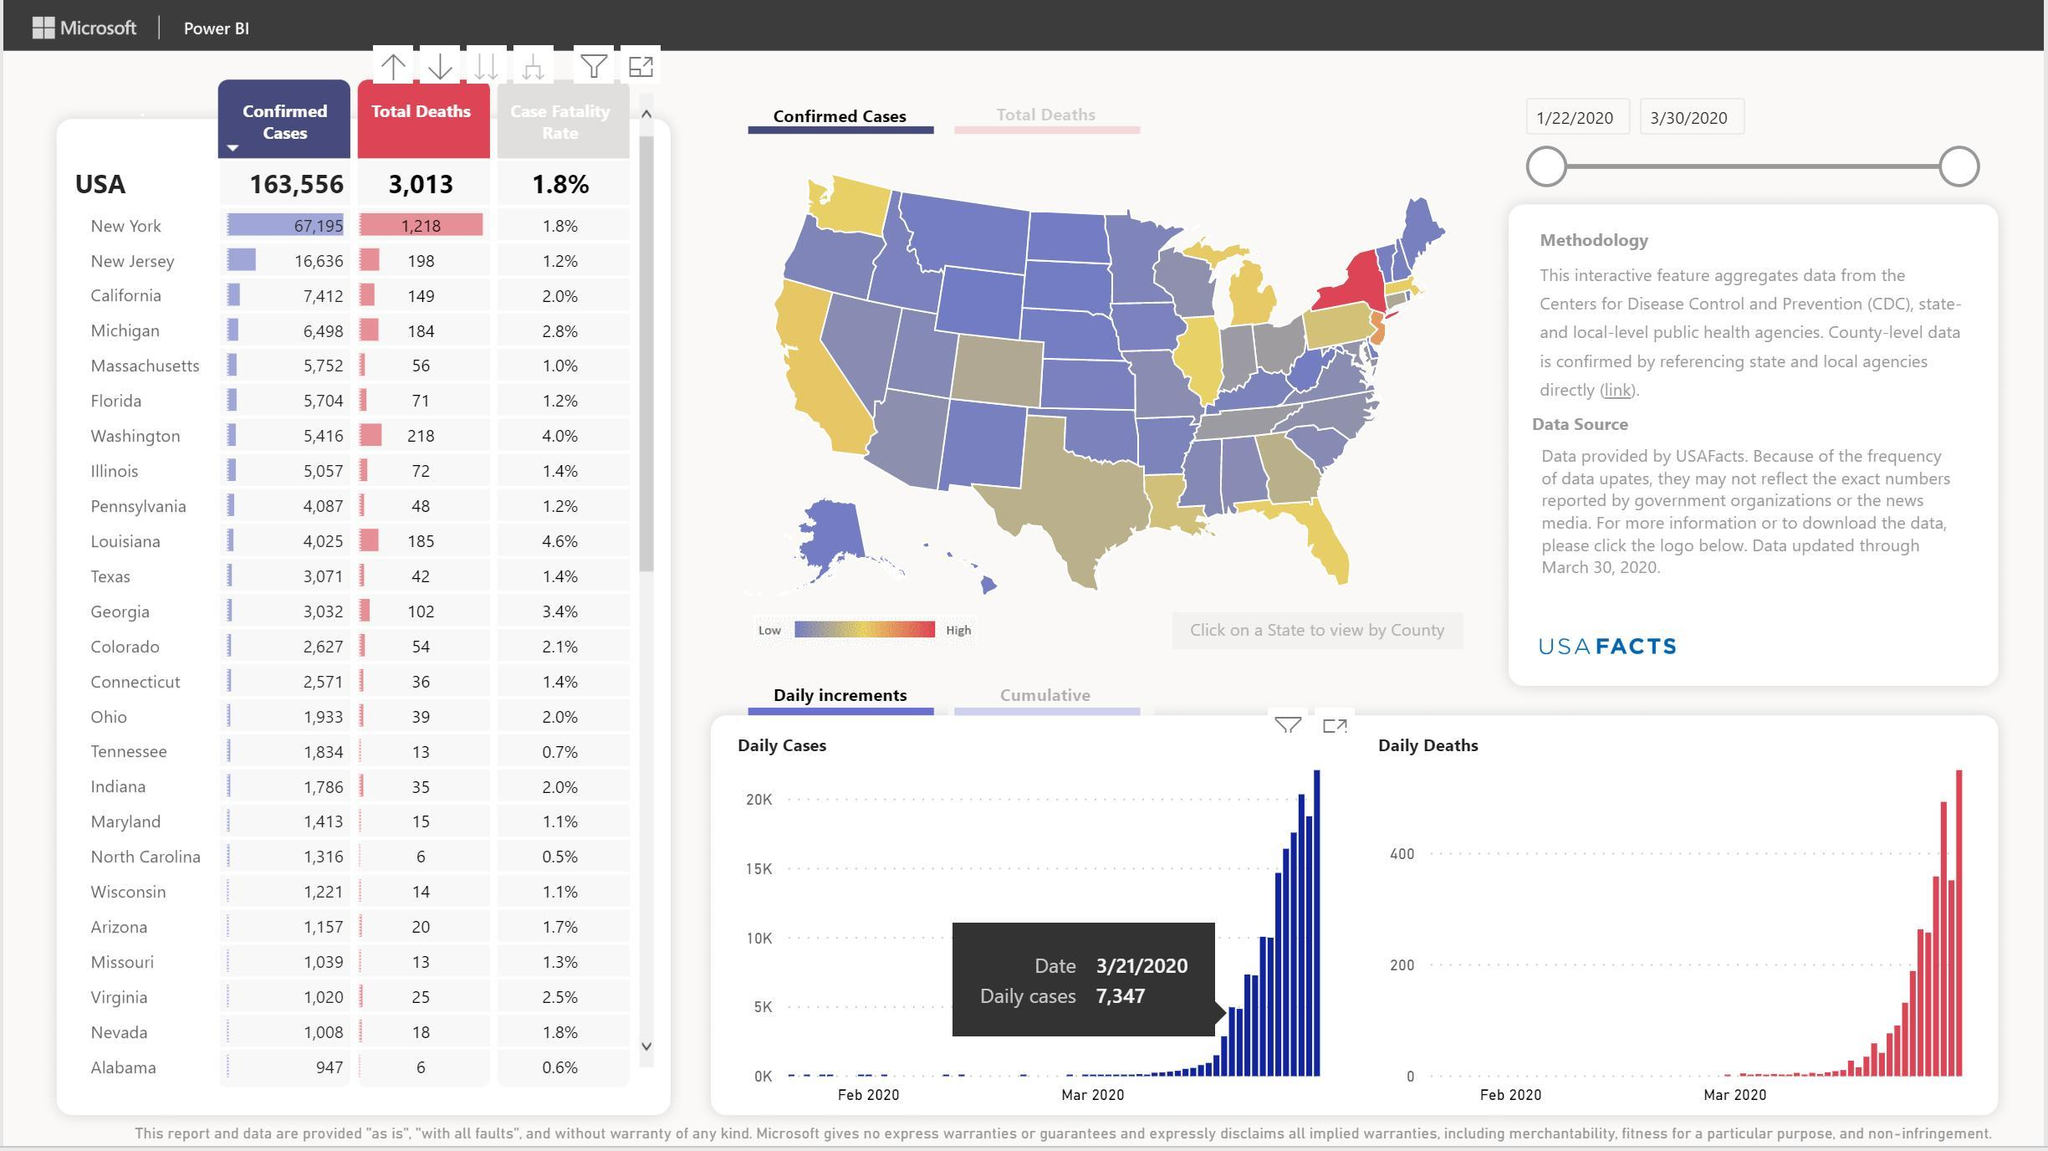Which states have a death count of 6
Answer the question with a short phrase. Alabama, North Carolina What is the total death in New York and New Jersey 1416 Which states have case fatality of less than 1% Alabama, North Carolina, Tennessee The case fatality rate of which states is same as USA New York, Nevada What is the total confirmed cases in Pennsylvania and Wisconsin 5308 